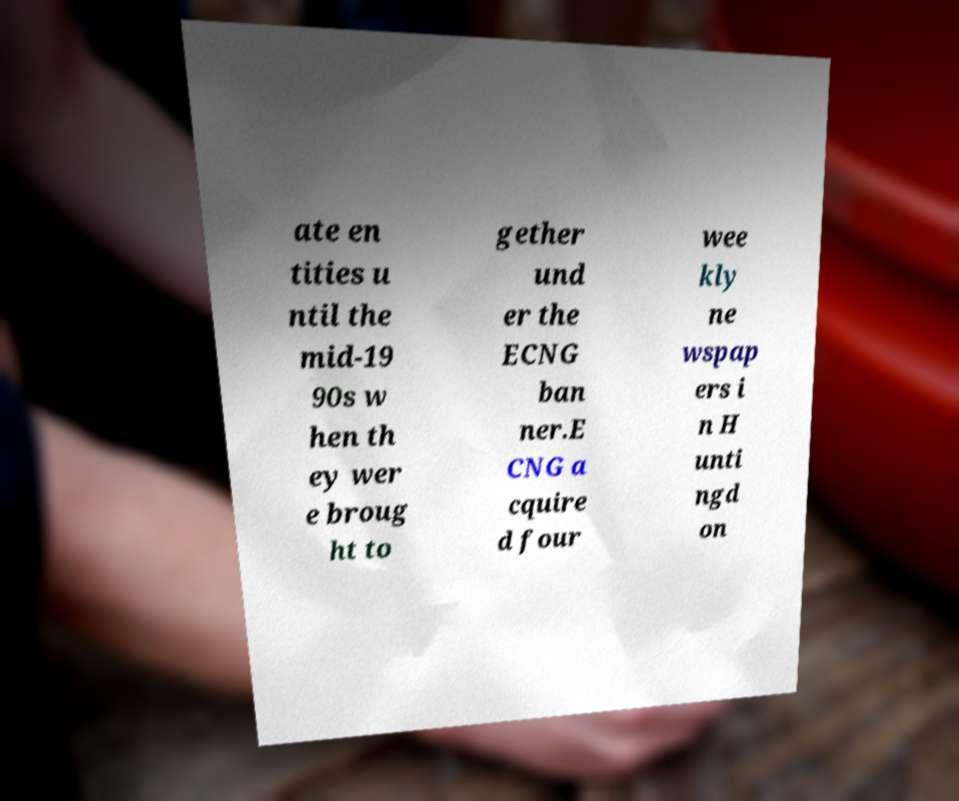For documentation purposes, I need the text within this image transcribed. Could you provide that? ate en tities u ntil the mid-19 90s w hen th ey wer e broug ht to gether und er the ECNG ban ner.E CNG a cquire d four wee kly ne wspap ers i n H unti ngd on 